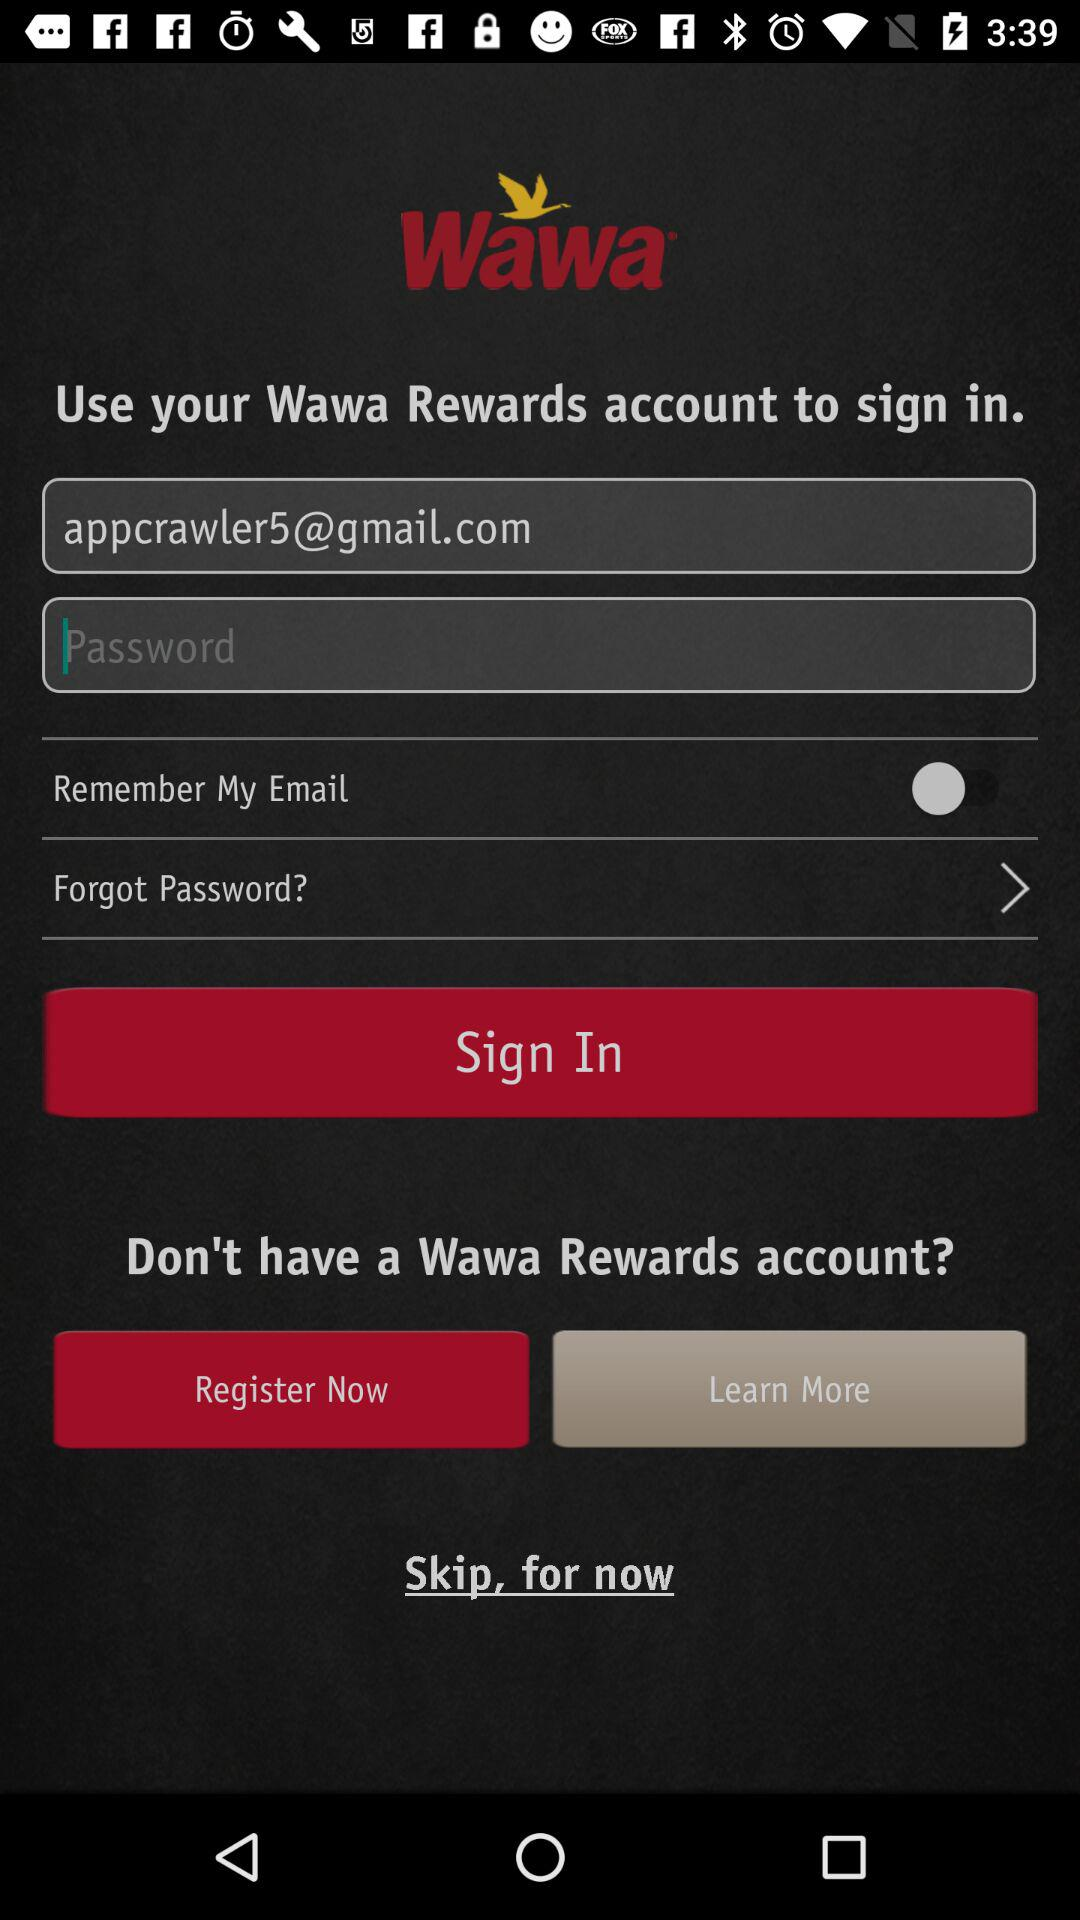What is the status of "Remember My Email"? The status of "Remember My Email" is "off". 